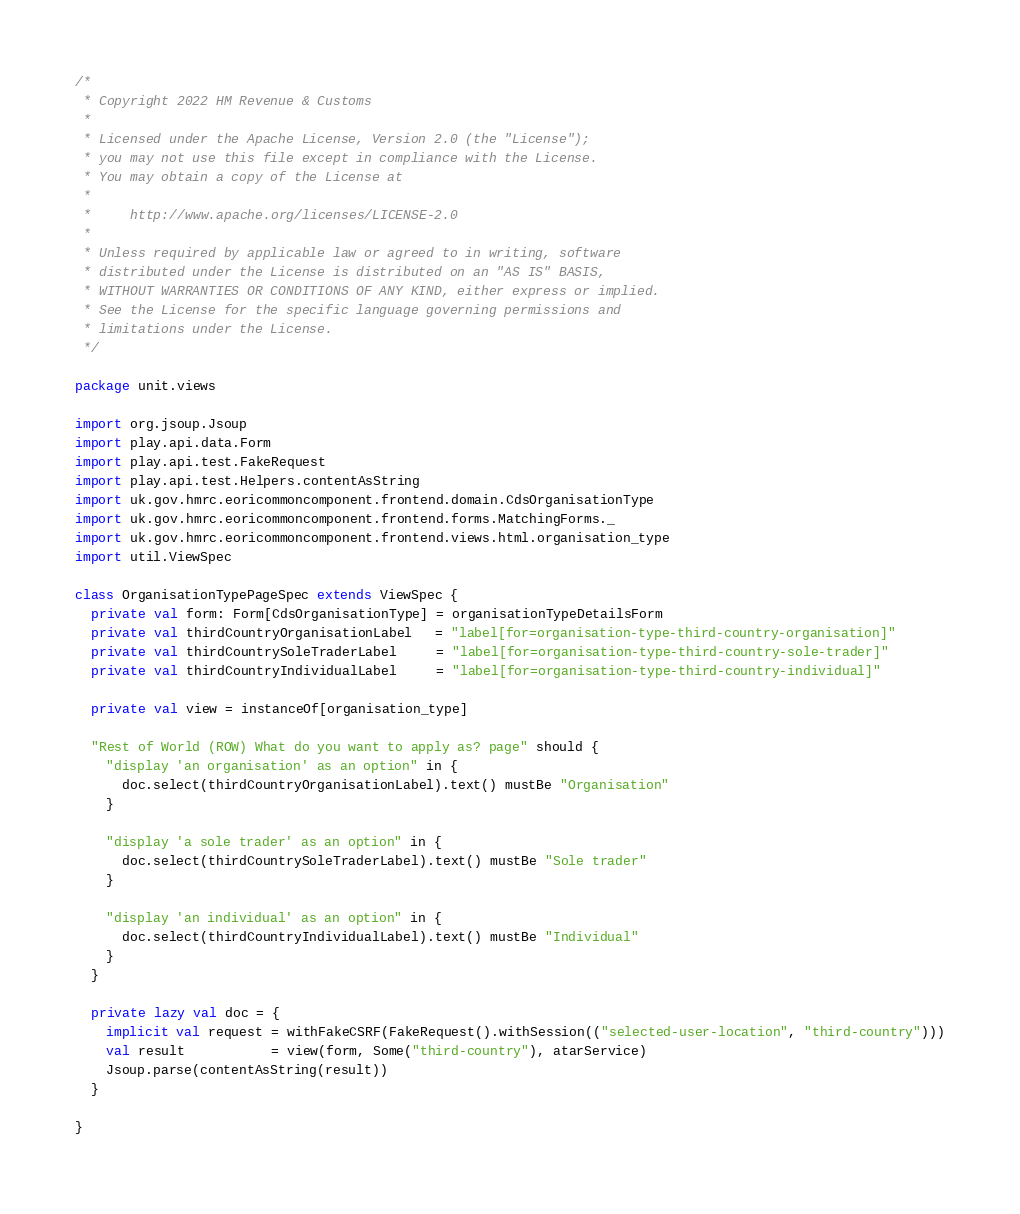<code> <loc_0><loc_0><loc_500><loc_500><_Scala_>/*
 * Copyright 2022 HM Revenue & Customs
 *
 * Licensed under the Apache License, Version 2.0 (the "License");
 * you may not use this file except in compliance with the License.
 * You may obtain a copy of the License at
 *
 *     http://www.apache.org/licenses/LICENSE-2.0
 *
 * Unless required by applicable law or agreed to in writing, software
 * distributed under the License is distributed on an "AS IS" BASIS,
 * WITHOUT WARRANTIES OR CONDITIONS OF ANY KIND, either express or implied.
 * See the License for the specific language governing permissions and
 * limitations under the License.
 */

package unit.views

import org.jsoup.Jsoup
import play.api.data.Form
import play.api.test.FakeRequest
import play.api.test.Helpers.contentAsString
import uk.gov.hmrc.eoricommoncomponent.frontend.domain.CdsOrganisationType
import uk.gov.hmrc.eoricommoncomponent.frontend.forms.MatchingForms._
import uk.gov.hmrc.eoricommoncomponent.frontend.views.html.organisation_type
import util.ViewSpec

class OrganisationTypePageSpec extends ViewSpec {
  private val form: Form[CdsOrganisationType] = organisationTypeDetailsForm
  private val thirdCountryOrganisationLabel   = "label[for=organisation-type-third-country-organisation]"
  private val thirdCountrySoleTraderLabel     = "label[for=organisation-type-third-country-sole-trader]"
  private val thirdCountryIndividualLabel     = "label[for=organisation-type-third-country-individual]"

  private val view = instanceOf[organisation_type]

  "Rest of World (ROW) What do you want to apply as? page" should {
    "display 'an organisation' as an option" in {
      doc.select(thirdCountryOrganisationLabel).text() mustBe "Organisation"
    }

    "display 'a sole trader' as an option" in {
      doc.select(thirdCountrySoleTraderLabel).text() mustBe "Sole trader"
    }

    "display 'an individual' as an option" in {
      doc.select(thirdCountryIndividualLabel).text() mustBe "Individual"
    }
  }

  private lazy val doc = {
    implicit val request = withFakeCSRF(FakeRequest().withSession(("selected-user-location", "third-country")))
    val result           = view(form, Some("third-country"), atarService)
    Jsoup.parse(contentAsString(result))
  }

}
</code> 